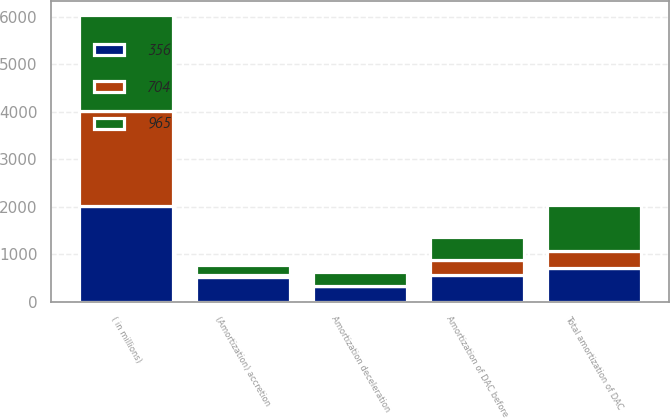Convert chart to OTSL. <chart><loc_0><loc_0><loc_500><loc_500><stacked_bar_chart><ecel><fcel>( in millions)<fcel>Amortization of DAC before<fcel>(Amortization) accretion<fcel>Amortization deceleration<fcel>Total amortization of DAC<nl><fcel>704<fcel>2010<fcel>326<fcel>42<fcel>12<fcel>356<nl><fcel>965<fcel>2009<fcel>472<fcel>216<fcel>277<fcel>965<nl><fcel>356<fcel>2008<fcel>556<fcel>515<fcel>327<fcel>704<nl></chart> 